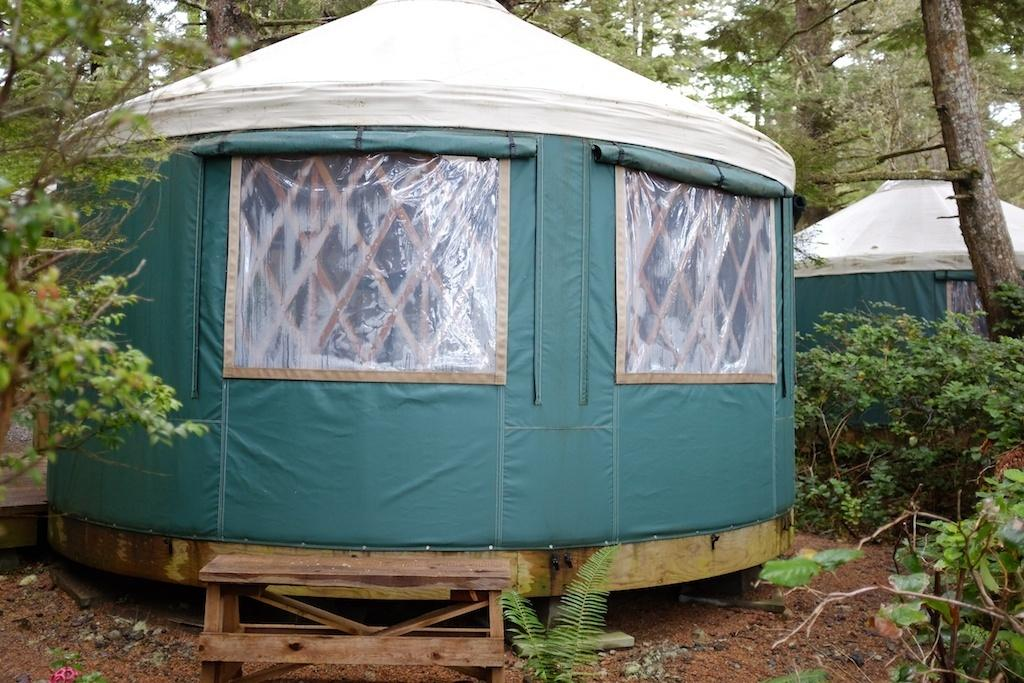What type of structure is located in the middle of the image? There is a tent house in the middle of the image. What other natural elements can be seen in the image? There are plants and trees in the image. Where are the tent house, plants, and trees situated? The tent house, plants, and trees are on land. What type of map is visible on the tent house in the image? There is no map visible on the tent house in the image. How many people are feasting on the plants in the image? There are no people feasting on the plants in the image; it only shows the tent house, plants, and trees. 